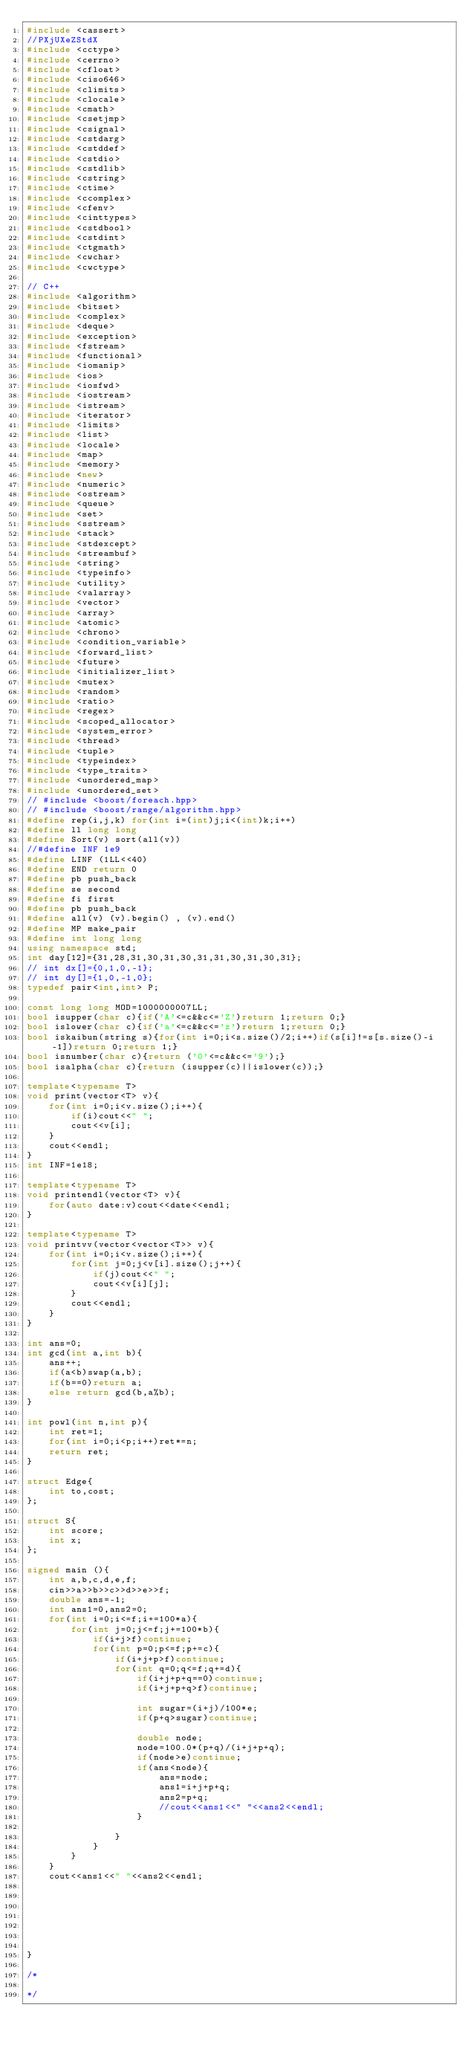Convert code to text. <code><loc_0><loc_0><loc_500><loc_500><_C++_>#include <cassert>
//PXjUXeZStdX
#include <cctype>
#include <cerrno>
#include <cfloat>
#include <ciso646>
#include <climits>
#include <clocale>
#include <cmath>
#include <csetjmp>
#include <csignal>
#include <cstdarg>
#include <cstddef>
#include <cstdio>
#include <cstdlib>
#include <cstring>
#include <ctime>
#include <ccomplex>
#include <cfenv>
#include <cinttypes>
#include <cstdbool>
#include <cstdint>
#include <ctgmath>
#include <cwchar>
#include <cwctype>

// C++
#include <algorithm>
#include <bitset>
#include <complex>
#include <deque>
#include <exception>
#include <fstream>
#include <functional>
#include <iomanip>
#include <ios>
#include <iosfwd>
#include <iostream>
#include <istream>
#include <iterator>
#include <limits>
#include <list>
#include <locale>
#include <map>
#include <memory>
#include <new>
#include <numeric>
#include <ostream>
#include <queue>
#include <set>
#include <sstream>
#include <stack>
#include <stdexcept>
#include <streambuf>
#include <string>
#include <typeinfo>
#include <utility>
#include <valarray>
#include <vector>
#include <array>
#include <atomic>
#include <chrono>
#include <condition_variable>
#include <forward_list>
#include <future>
#include <initializer_list>
#include <mutex>
#include <random>
#include <ratio>
#include <regex>
#include <scoped_allocator>
#include <system_error>
#include <thread>
#include <tuple>
#include <typeindex>
#include <type_traits>
#include <unordered_map>
#include <unordered_set>
// #include <boost/foreach.hpp>
// #include <boost/range/algorithm.hpp>
#define rep(i,j,k) for(int i=(int)j;i<(int)k;i++)
#define ll long long
#define Sort(v) sort(all(v))
//#define INF 1e9
#define LINF (1LL<<40)
#define END return 0
#define pb push_back
#define se second
#define fi first
#define pb push_back
#define all(v) (v).begin() , (v).end()
#define MP make_pair
#define int long long
using namespace std;
int day[12]={31,28,31,30,31,30,31,31,30,31,30,31};
// int dx[]={0,1,0,-1};
// int dy[]={1,0,-1,0};
typedef pair<int,int> P;

const long long MOD=1000000007LL;
bool isupper(char c){if('A'<=c&&c<='Z')return 1;return 0;}
bool islower(char c){if('a'<=c&&c<='z')return 1;return 0;}
bool iskaibun(string s){for(int i=0;i<s.size()/2;i++)if(s[i]!=s[s.size()-i-1])return 0;return 1;}
bool isnumber(char c){return ('0'<=c&&c<='9');}
bool isalpha(char c){return (isupper(c)||islower(c));}

template<typename T> 
void print(vector<T> v){
    for(int i=0;i<v.size();i++){
        if(i)cout<<" ";
        cout<<v[i];
    }
    cout<<endl;
}
int INF=1e18;

template<typename T>
void printendl(vector<T> v){
    for(auto date:v)cout<<date<<endl;
}

template<typename T>
void printvv(vector<vector<T>> v){
    for(int i=0;i<v.size();i++){
        for(int j=0;j<v[i].size();j++){
            if(j)cout<<" ";
            cout<<v[i][j];
        }
        cout<<endl;
    }
}

int ans=0;
int gcd(int a,int b){
    ans++;
    if(a<b)swap(a,b);
    if(b==0)return a;
    else return gcd(b,a%b);
}

int powl(int n,int p){
    int ret=1;
    for(int i=0;i<p;i++)ret*=n;
    return ret;
}

struct Edge{
    int to,cost;
};

struct S{
    int score;
    int x;
};

signed main (){
    int a,b,c,d,e,f;
    cin>>a>>b>>c>>d>>e>>f;
    double ans=-1;
    int ans1=0,ans2=0;
    for(int i=0;i<=f;i+=100*a){
        for(int j=0;j<=f;j+=100*b){
            if(i+j>f)continue;
            for(int p=0;p<=f;p+=c){
                if(i+j+p>f)continue;
                for(int q=0;q<=f;q+=d){
                    if(i+j+p+q==0)continue;
                    if(i+j+p+q>f)continue;

                    int sugar=(i+j)/100*e;
                    if(p+q>sugar)continue;

                    double node;
                    node=100.0*(p+q)/(i+j+p+q);
                    if(node>e)continue;
                    if(ans<node){
                        ans=node;
                        ans1=i+j+p+q;
                        ans2=p+q;
                        //cout<<ans1<<" "<<ans2<<endl;
                    }
                    
                }
            }
        }
    }
    cout<<ans1<<" "<<ans2<<endl;


    

    


}

/*

*/</code> 